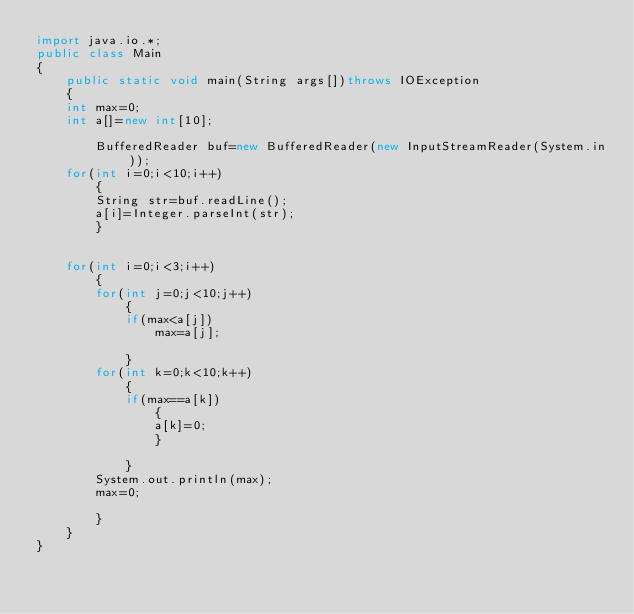Convert code to text. <code><loc_0><loc_0><loc_500><loc_500><_Java_>import java.io.*;
public class Main
{
    public static void main(String args[])throws IOException
    {
	int max=0;
	int a[]=new int[10];

      	BufferedReader buf=new BufferedReader(new InputStreamReader(System.in));
	for(int i=0;i<10;i++)
	    {
		String str=buf.readLine();
		a[i]=Integer.parseInt(str);
	    }

	
	for(int i=0;i<3;i++)
	    {
		for(int j=0;j<10;j++)
		    {
			if(max<a[j])
			    max=a[j];
		
		    }
		for(int k=0;k<10;k++)
		    {
			if(max==a[k])
			    {
				a[k]=0;
			    }
		
		    }
		System.out.println(max);
		max=0;
	
	    }
    }
}</code> 